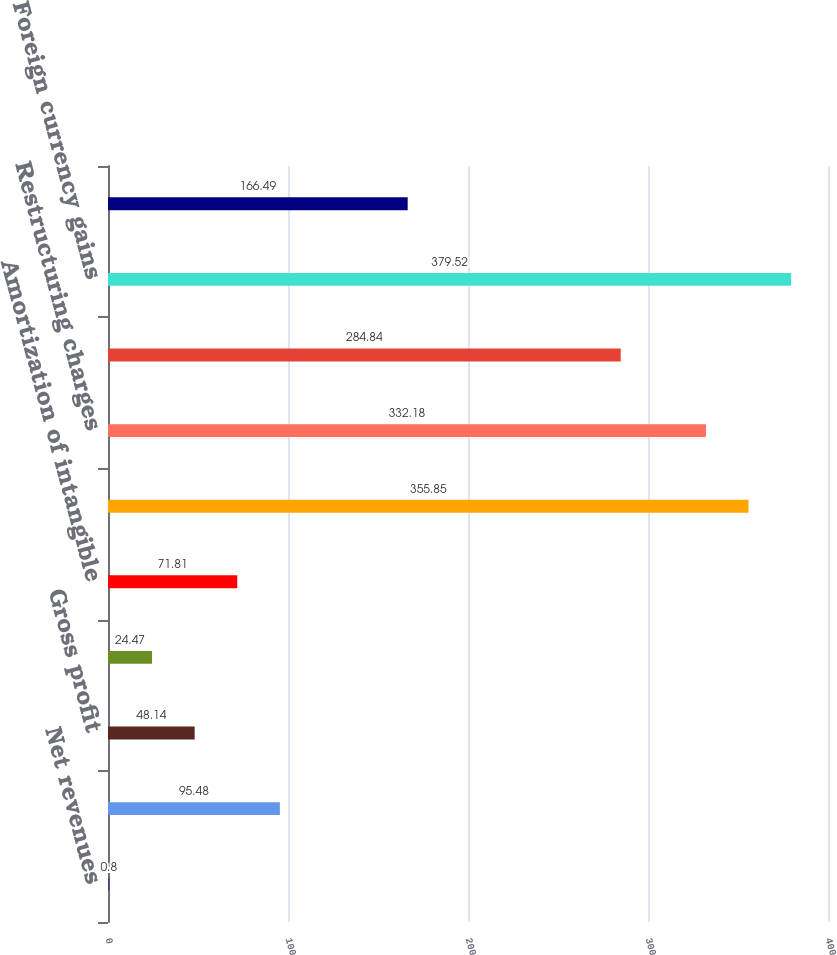Convert chart. <chart><loc_0><loc_0><loc_500><loc_500><bar_chart><fcel>Net revenues<fcel>Cost of goods sold (a)<fcel>Gross profit<fcel>Selling general and<fcel>Amortization of intangible<fcel>Impairments of assets<fcel>Restructuring charges<fcel>Operating income<fcel>Foreign currency gains<fcel>Interest expense<nl><fcel>0.8<fcel>95.48<fcel>48.14<fcel>24.47<fcel>71.81<fcel>355.85<fcel>332.18<fcel>284.84<fcel>379.52<fcel>166.49<nl></chart> 